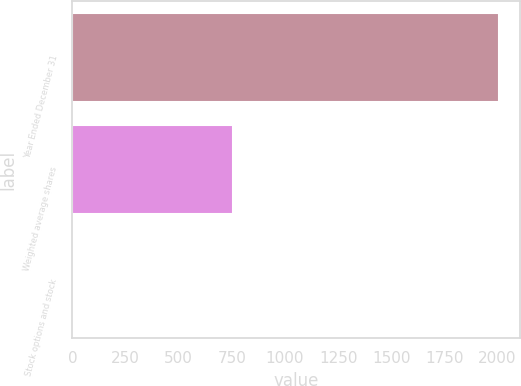<chart> <loc_0><loc_0><loc_500><loc_500><bar_chart><fcel>Year Ended December 31<fcel>Weighted average shares<fcel>Stock options and stock<nl><fcel>2005<fcel>757.51<fcel>0.86<nl></chart> 